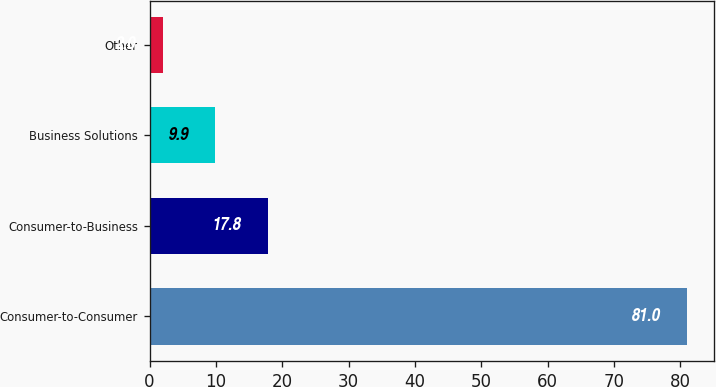Convert chart. <chart><loc_0><loc_0><loc_500><loc_500><bar_chart><fcel>Consumer-to-Consumer<fcel>Consumer-to-Business<fcel>Business Solutions<fcel>Other<nl><fcel>81<fcel>17.8<fcel>9.9<fcel>2<nl></chart> 